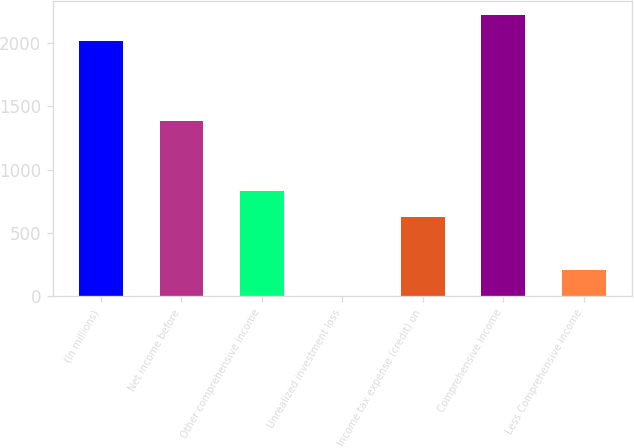Convert chart to OTSL. <chart><loc_0><loc_0><loc_500><loc_500><bar_chart><fcel>(In millions)<fcel>Net income before<fcel>Other comprehensive income<fcel>Unrealized investment loss<fcel>Income tax expense (credit) on<fcel>Comprehensive income<fcel>Less Comprehensive income<nl><fcel>2013<fcel>1385<fcel>829<fcel>1<fcel>622<fcel>2220<fcel>208<nl></chart> 